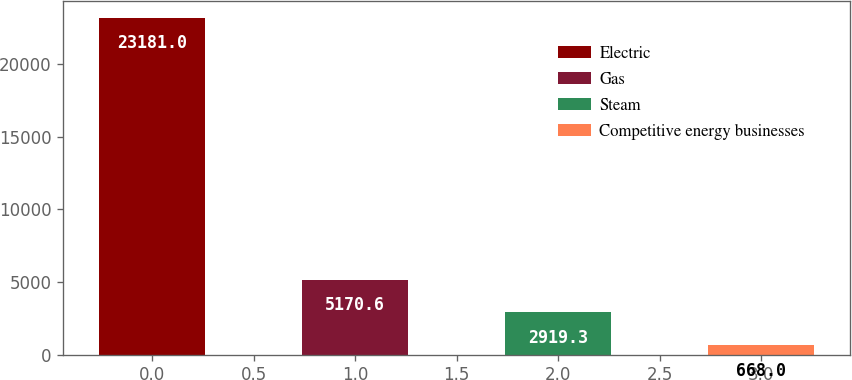Convert chart. <chart><loc_0><loc_0><loc_500><loc_500><bar_chart><fcel>Electric<fcel>Gas<fcel>Steam<fcel>Competitive energy businesses<nl><fcel>23181<fcel>5170.6<fcel>2919.3<fcel>668<nl></chart> 